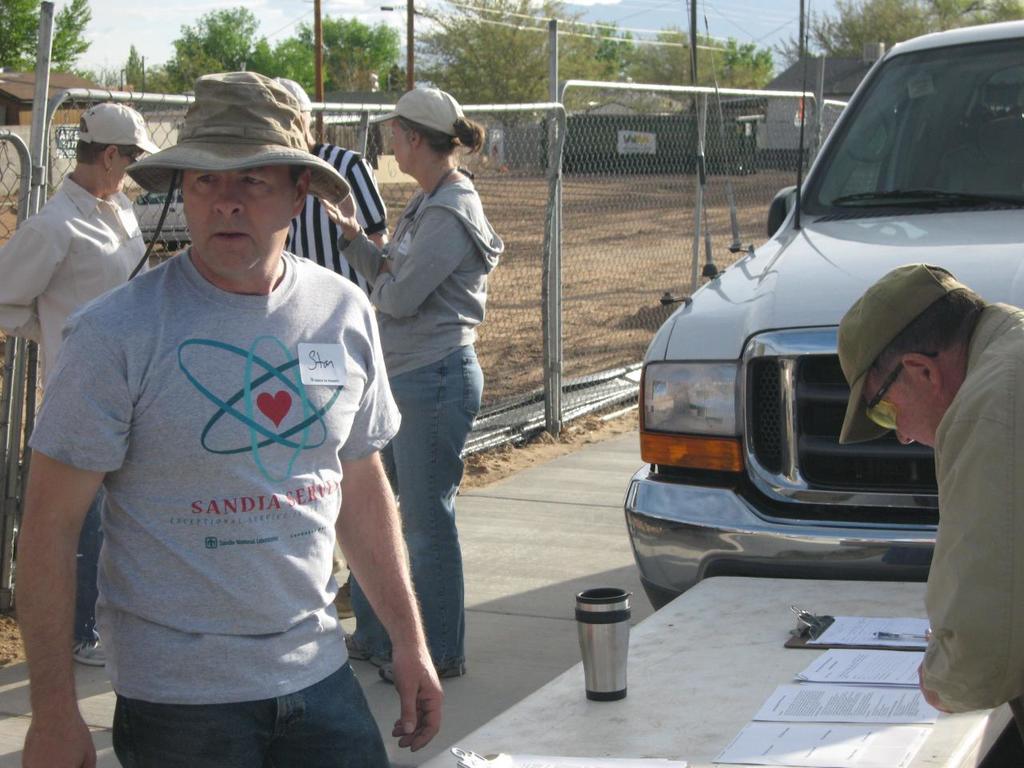Please provide a concise description of this image. In this image I can see a person wearing grey t shirt, blue jeans and hat is standing in front of a table and another person is standing on other side of the table. On the table I can see a glass, a pad and few papers. In the background I can see few other persons standing, a car on the road, the metal fencing, few trees, a building, few poles and the sky. 